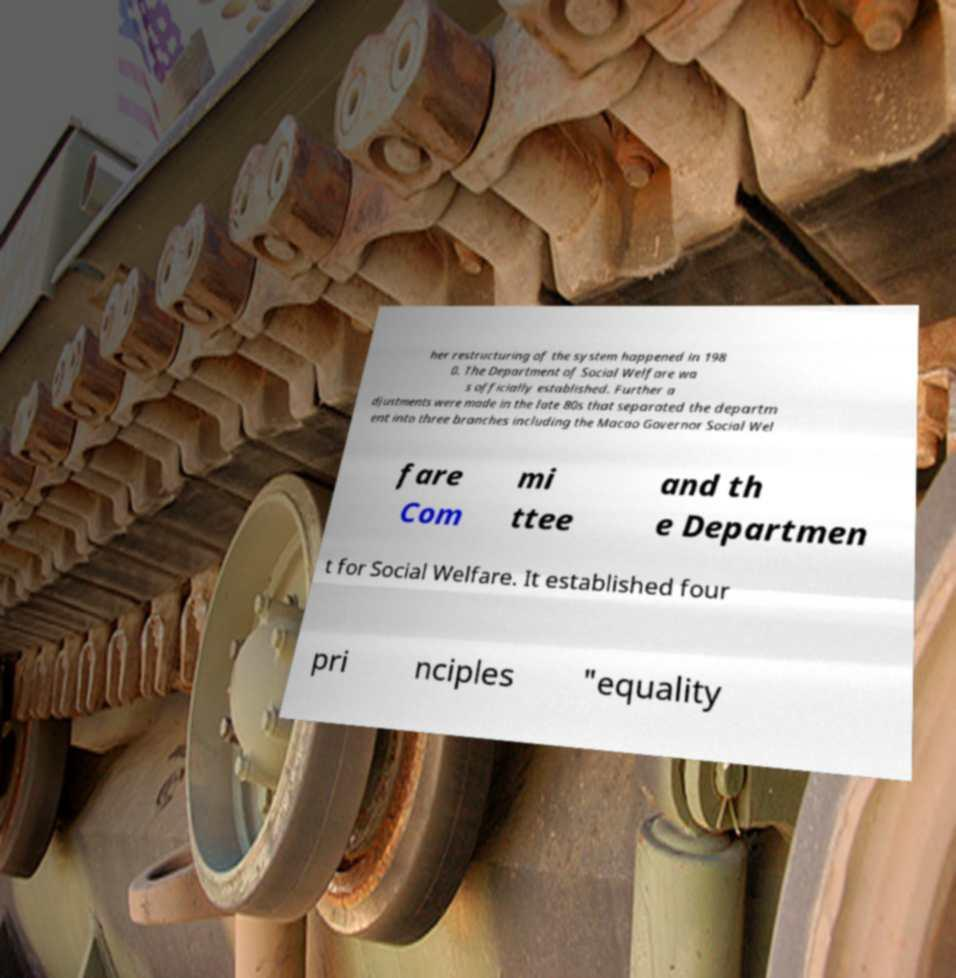There's text embedded in this image that I need extracted. Can you transcribe it verbatim? her restructuring of the system happened in 198 0. The Department of Social Welfare wa s officially established. Further a djustments were made in the late 80s that separated the departm ent into three branches including the Macao Governor Social Wel fare Com mi ttee and th e Departmen t for Social Welfare. It established four pri nciples "equality 